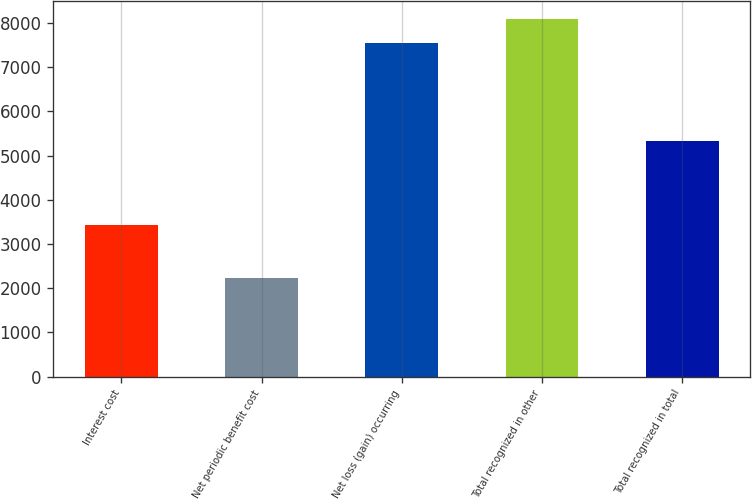Convert chart to OTSL. <chart><loc_0><loc_0><loc_500><loc_500><bar_chart><fcel>Interest cost<fcel>Net periodic benefit cost<fcel>Net loss (gain) occurring<fcel>Total recognized in other<fcel>Total recognized in total<nl><fcel>3434<fcel>2231<fcel>7553<fcel>8085.2<fcel>5322<nl></chart> 